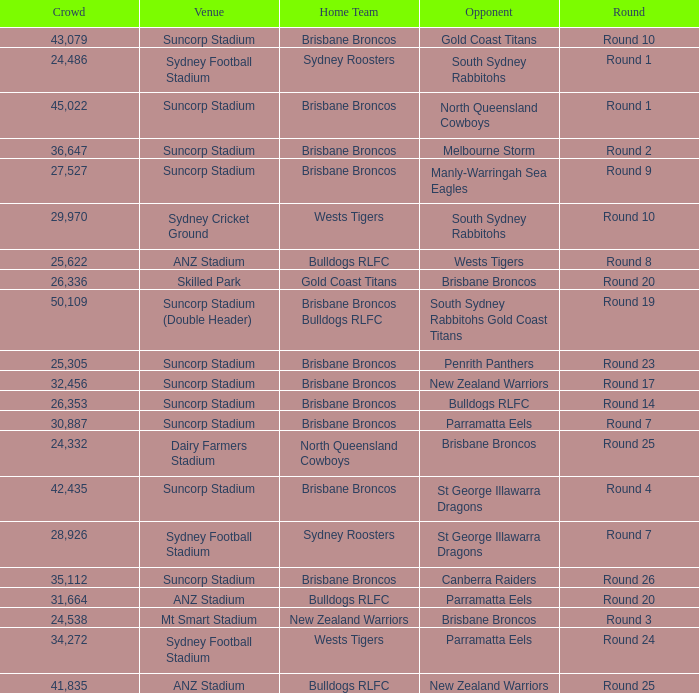What was the attendance at Round 9? 1.0. Write the full table. {'header': ['Crowd', 'Venue', 'Home Team', 'Opponent', 'Round'], 'rows': [['43,079', 'Suncorp Stadium', 'Brisbane Broncos', 'Gold Coast Titans', 'Round 10'], ['24,486', 'Sydney Football Stadium', 'Sydney Roosters', 'South Sydney Rabbitohs', 'Round 1'], ['45,022', 'Suncorp Stadium', 'Brisbane Broncos', 'North Queensland Cowboys', 'Round 1'], ['36,647', 'Suncorp Stadium', 'Brisbane Broncos', 'Melbourne Storm', 'Round 2'], ['27,527', 'Suncorp Stadium', 'Brisbane Broncos', 'Manly-Warringah Sea Eagles', 'Round 9'], ['29,970', 'Sydney Cricket Ground', 'Wests Tigers', 'South Sydney Rabbitohs', 'Round 10'], ['25,622', 'ANZ Stadium', 'Bulldogs RLFC', 'Wests Tigers', 'Round 8'], ['26,336', 'Skilled Park', 'Gold Coast Titans', 'Brisbane Broncos', 'Round 20'], ['50,109', 'Suncorp Stadium (Double Header)', 'Brisbane Broncos Bulldogs RLFC', 'South Sydney Rabbitohs Gold Coast Titans', 'Round 19'], ['25,305', 'Suncorp Stadium', 'Brisbane Broncos', 'Penrith Panthers', 'Round 23'], ['32,456', 'Suncorp Stadium', 'Brisbane Broncos', 'New Zealand Warriors', 'Round 17'], ['26,353', 'Suncorp Stadium', 'Brisbane Broncos', 'Bulldogs RLFC', 'Round 14'], ['30,887', 'Suncorp Stadium', 'Brisbane Broncos', 'Parramatta Eels', 'Round 7'], ['24,332', 'Dairy Farmers Stadium', 'North Queensland Cowboys', 'Brisbane Broncos', 'Round 25'], ['42,435', 'Suncorp Stadium', 'Brisbane Broncos', 'St George Illawarra Dragons', 'Round 4'], ['28,926', 'Sydney Football Stadium', 'Sydney Roosters', 'St George Illawarra Dragons', 'Round 7'], ['35,112', 'Suncorp Stadium', 'Brisbane Broncos', 'Canberra Raiders', 'Round 26'], ['31,664', 'ANZ Stadium', 'Bulldogs RLFC', 'Parramatta Eels', 'Round 20'], ['24,538', 'Mt Smart Stadium', 'New Zealand Warriors', 'Brisbane Broncos', 'Round 3'], ['34,272', 'Sydney Football Stadium', 'Wests Tigers', 'Parramatta Eels', 'Round 24'], ['41,835', 'ANZ Stadium', 'Bulldogs RLFC', 'New Zealand Warriors', 'Round 25']]} 